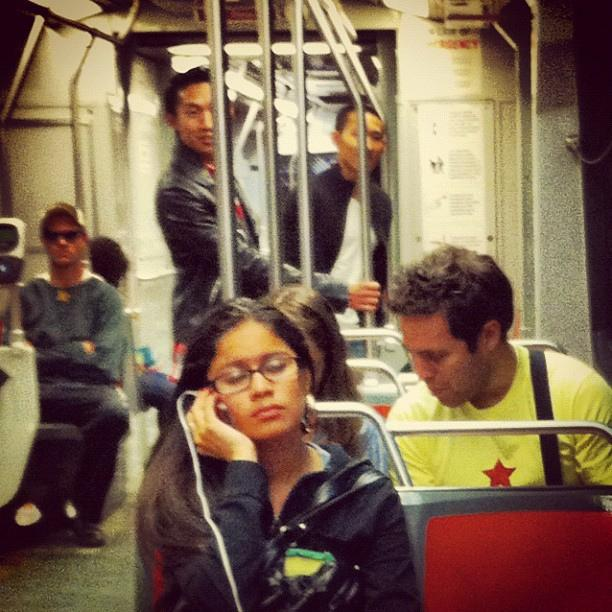The shape the man has on his yellow shirt is found on what flag? Please explain your reasoning. china. There is a man sitting behind a woman listening to music. he has a red star on chest which can be found in asian country. 